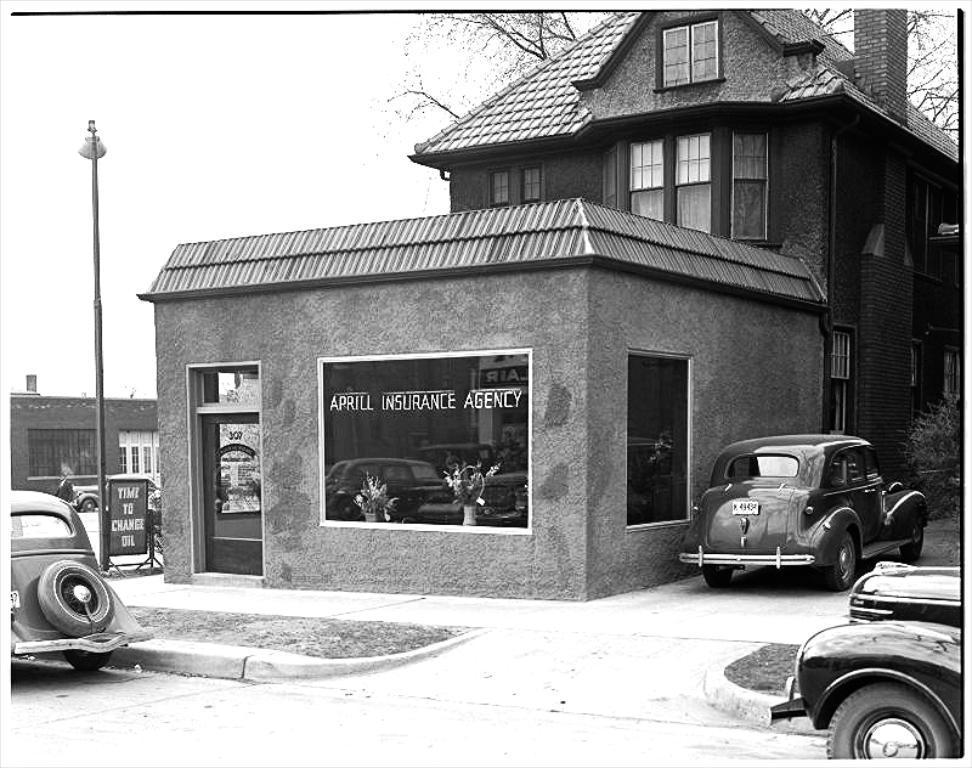In one or two sentences, can you explain what this image depicts? In the image we can see there are buildings and there are cars parked on the road. There are trees and the image is in black and white colour. There is a street light pole on the footpath. 